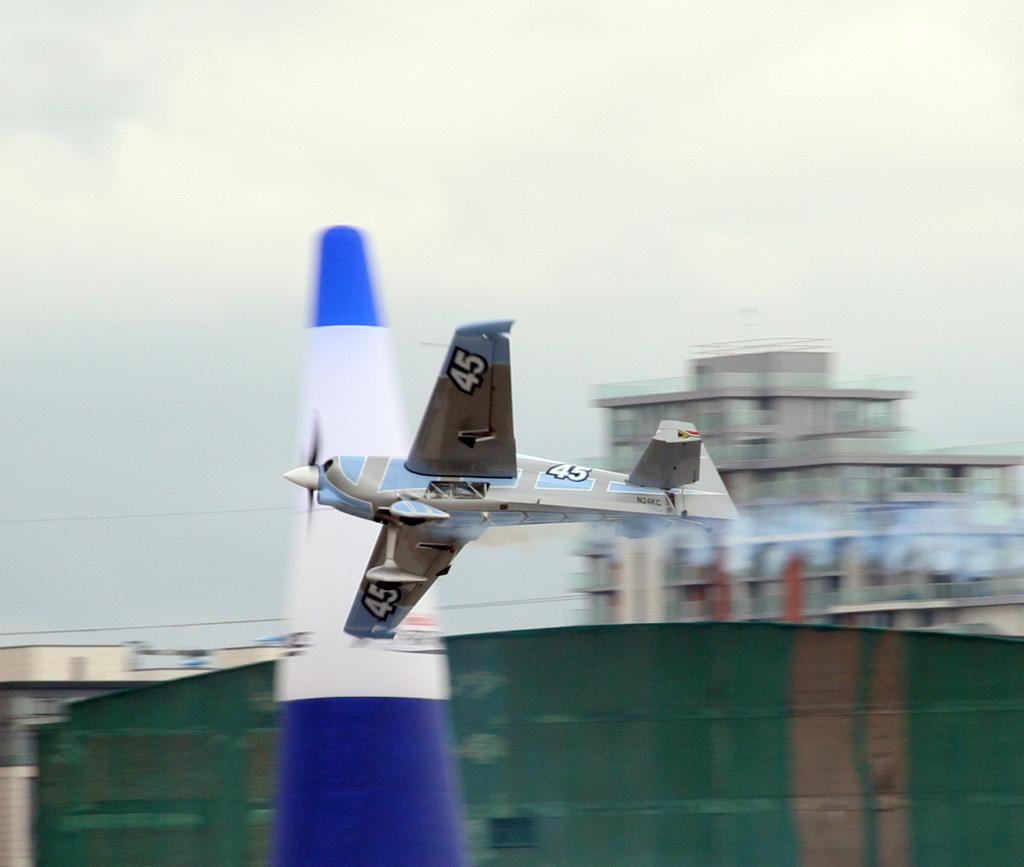<image>
Render a clear and concise summary of the photo. the number 45 is on the wing of the plane 